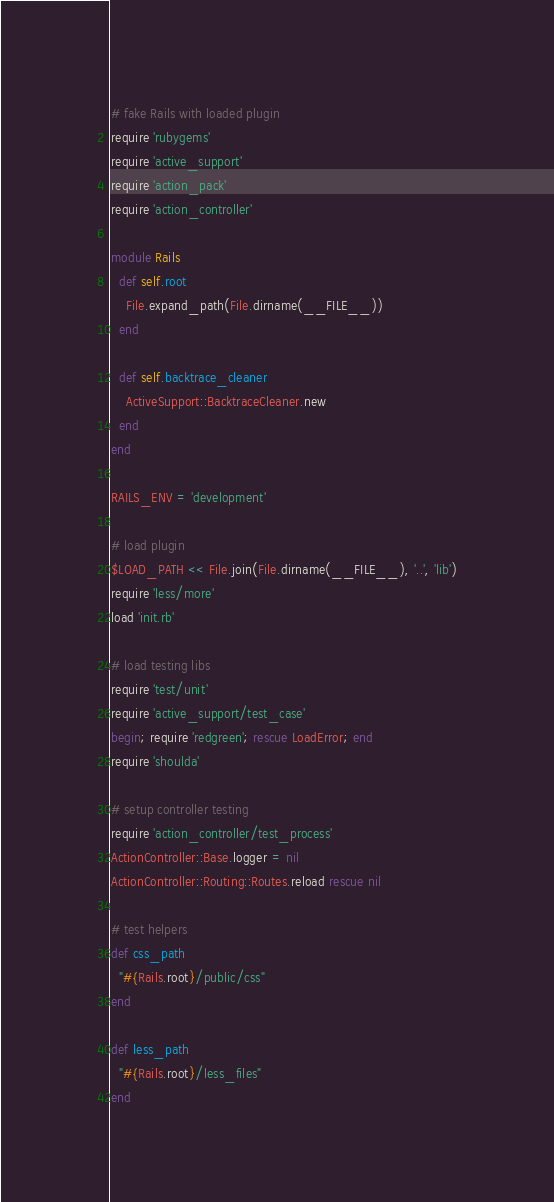<code> <loc_0><loc_0><loc_500><loc_500><_Ruby_># fake Rails with loaded plugin
require 'rubygems'
require 'active_support'
require 'action_pack'
require 'action_controller'

module Rails
  def self.root
    File.expand_path(File.dirname(__FILE__))
  end

  def self.backtrace_cleaner
    ActiveSupport::BacktraceCleaner.new
  end
end

RAILS_ENV = 'development'

# load plugin
$LOAD_PATH << File.join(File.dirname(__FILE__), '..', 'lib')
require 'less/more'
load 'init.rb'

# load testing libs
require 'test/unit'
require 'active_support/test_case'
begin; require 'redgreen'; rescue LoadError; end
require 'shoulda'

# setup controller testing
require 'action_controller/test_process'
ActionController::Base.logger = nil
ActionController::Routing::Routes.reload rescue nil

# test helpers
def css_path
  "#{Rails.root}/public/css"
end

def less_path
  "#{Rails.root}/less_files"
end
</code> 